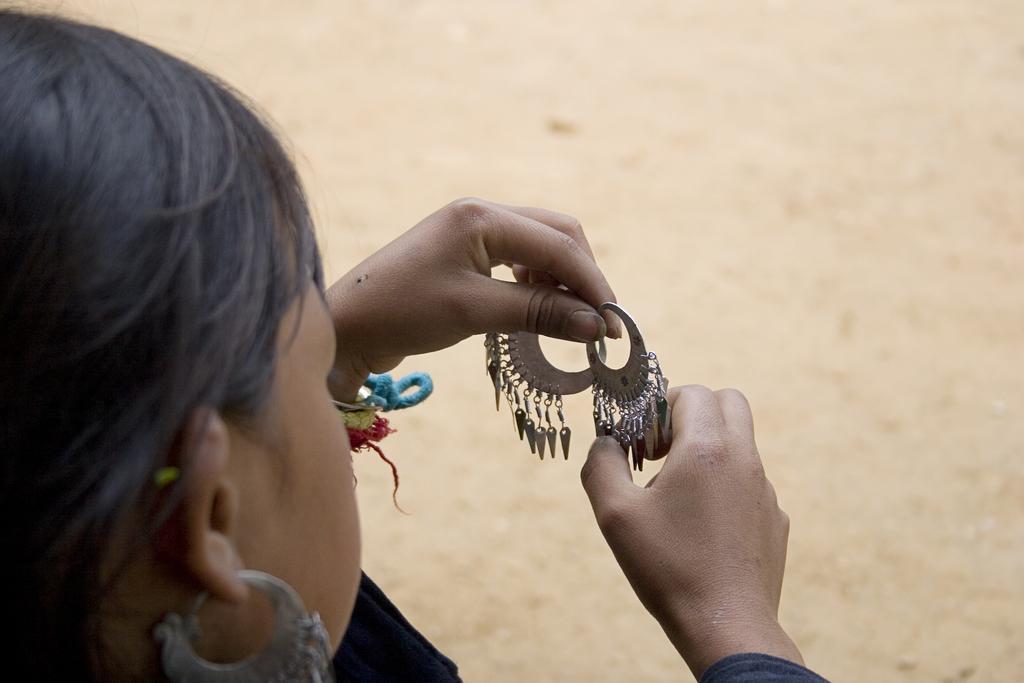Can you describe this image briefly? In this picture I can see a woman holding earrings. 